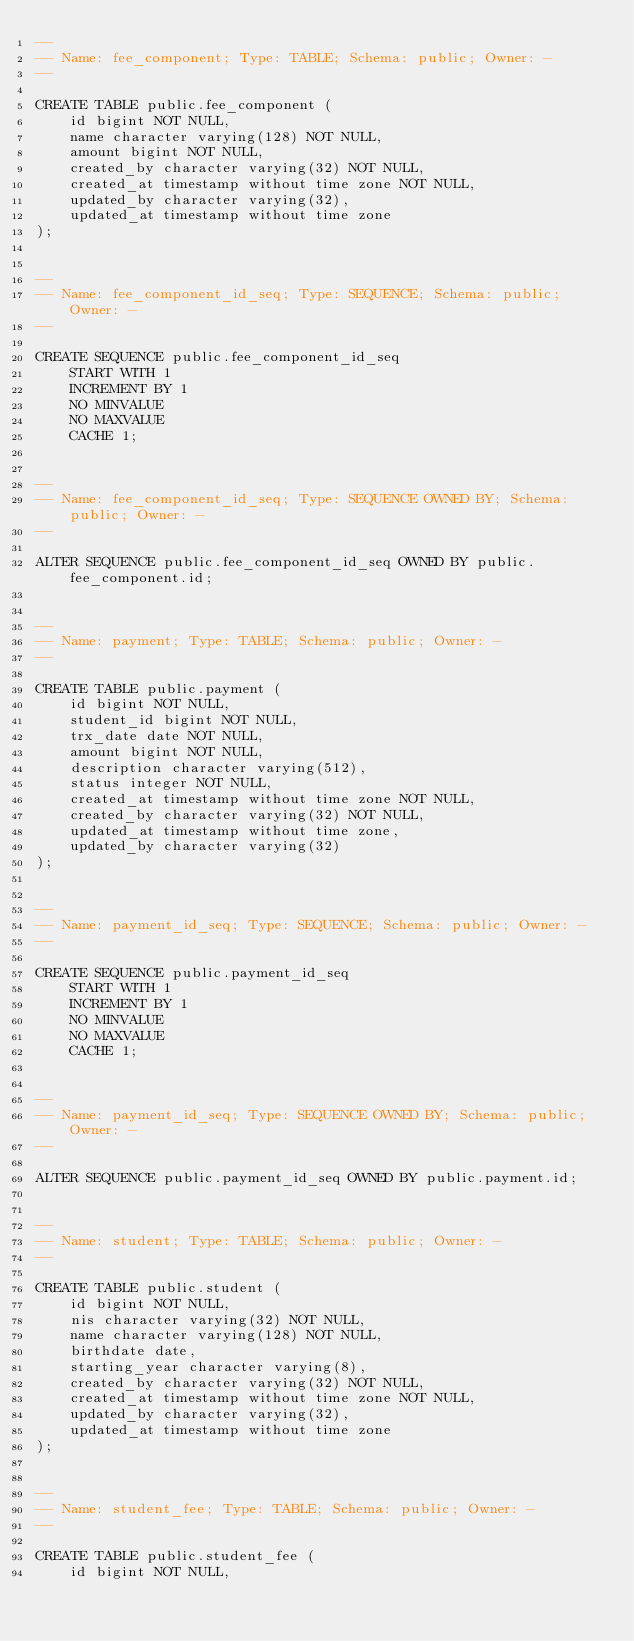Convert code to text. <code><loc_0><loc_0><loc_500><loc_500><_SQL_>--
-- Name: fee_component; Type: TABLE; Schema: public; Owner: -
--

CREATE TABLE public.fee_component (
    id bigint NOT NULL,
    name character varying(128) NOT NULL,
    amount bigint NOT NULL,
    created_by character varying(32) NOT NULL,
    created_at timestamp without time zone NOT NULL,
    updated_by character varying(32),
    updated_at timestamp without time zone
);


--
-- Name: fee_component_id_seq; Type: SEQUENCE; Schema: public; Owner: -
--

CREATE SEQUENCE public.fee_component_id_seq
    START WITH 1
    INCREMENT BY 1
    NO MINVALUE
    NO MAXVALUE
    CACHE 1;


--
-- Name: fee_component_id_seq; Type: SEQUENCE OWNED BY; Schema: public; Owner: -
--

ALTER SEQUENCE public.fee_component_id_seq OWNED BY public.fee_component.id;


--
-- Name: payment; Type: TABLE; Schema: public; Owner: -
--

CREATE TABLE public.payment (
    id bigint NOT NULL,
    student_id bigint NOT NULL,
    trx_date date NOT NULL,
    amount bigint NOT NULL,
    description character varying(512),
    status integer NOT NULL,
    created_at timestamp without time zone NOT NULL,
    created_by character varying(32) NOT NULL,
    updated_at timestamp without time zone,
    updated_by character varying(32)
);


--
-- Name: payment_id_seq; Type: SEQUENCE; Schema: public; Owner: -
--

CREATE SEQUENCE public.payment_id_seq
    START WITH 1
    INCREMENT BY 1
    NO MINVALUE
    NO MAXVALUE
    CACHE 1;


--
-- Name: payment_id_seq; Type: SEQUENCE OWNED BY; Schema: public; Owner: -
--

ALTER SEQUENCE public.payment_id_seq OWNED BY public.payment.id;


--
-- Name: student; Type: TABLE; Schema: public; Owner: -
--

CREATE TABLE public.student (
    id bigint NOT NULL,
    nis character varying(32) NOT NULL,
    name character varying(128) NOT NULL,
    birthdate date,
    starting_year character varying(8),
    created_by character varying(32) NOT NULL,
    created_at timestamp without time zone NOT NULL,
    updated_by character varying(32),
    updated_at timestamp without time zone
);


--
-- Name: student_fee; Type: TABLE; Schema: public; Owner: -
--

CREATE TABLE public.student_fee (
    id bigint NOT NULL,</code> 